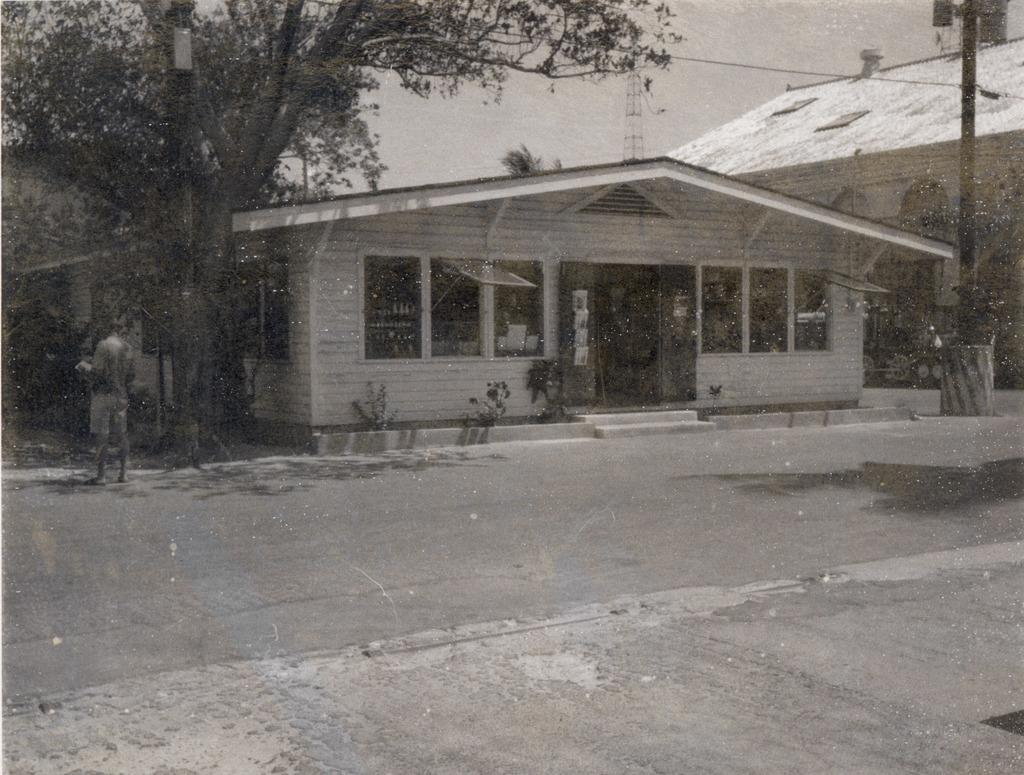What is the main subject of the image? There is a person standing in the image. What else can be seen in the image besides the person? There is a pole, a tree, buildings, and the clear sky in the image. Can you describe the pole in the image? The pole is a vertical structure that can be used for support or as a marker. What type of vegetation is present in the image? There is a tree in the image. How is the sky depicted in the image? The sky is clear in the image. What type of waste can be seen on the ground in the image? There is no waste visible on the ground in the image. What part of the tree is responsible for processing information in the image? Trees do not have brains or any part responsible for processing information; they are living organisms that produce oxygen and provide habitats for various species. 